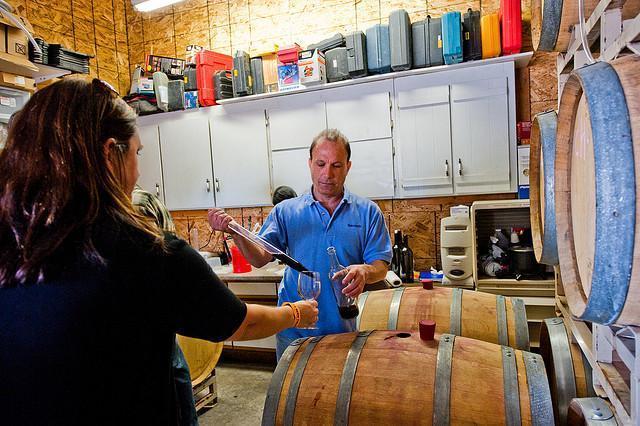How many people are in the picture?
Give a very brief answer. 2. How many people are there?
Give a very brief answer. 2. 